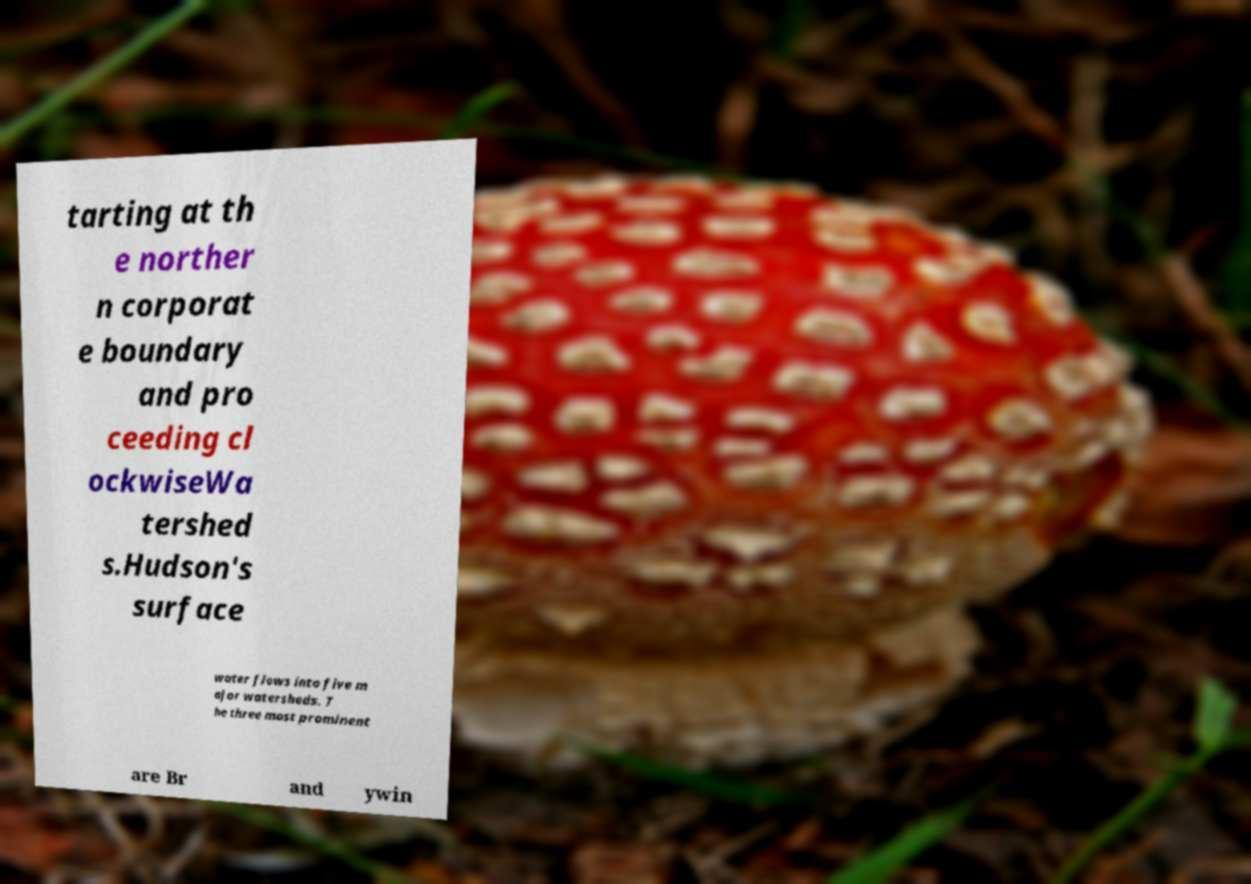What messages or text are displayed in this image? I need them in a readable, typed format. tarting at th e norther n corporat e boundary and pro ceeding cl ockwiseWa tershed s.Hudson's surface water flows into five m ajor watersheds. T he three most prominent are Br and ywin 